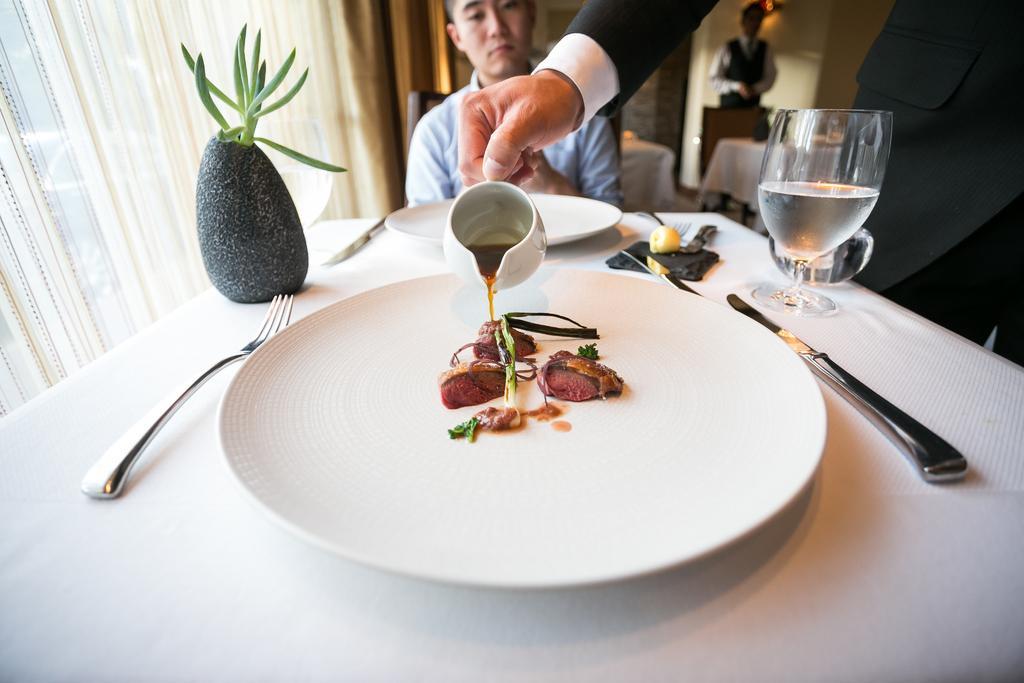In one or two sentences, can you explain what this image depicts? There is a table. There is a plate,fork,glass and food item on a table. He is sitting in a chair. We can see in the background there is a wall. 